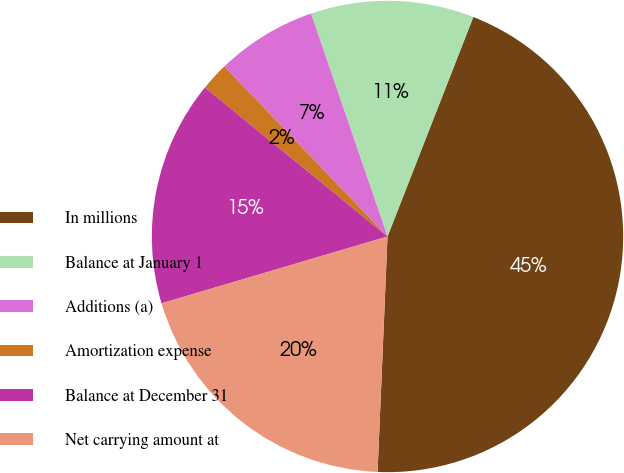Convert chart to OTSL. <chart><loc_0><loc_0><loc_500><loc_500><pie_chart><fcel>In millions<fcel>Balance at January 1<fcel>Additions (a)<fcel>Amortization expense<fcel>Balance at December 31<fcel>Net carrying amount at<nl><fcel>44.74%<fcel>11.19%<fcel>6.91%<fcel>1.94%<fcel>15.47%<fcel>19.75%<nl></chart> 